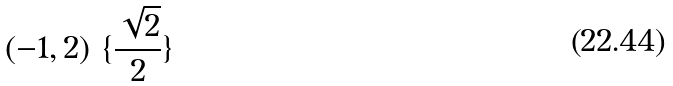<formula> <loc_0><loc_0><loc_500><loc_500>( - 1 , 2 ) \ \{ \frac { \sqrt { 2 } } { 2 } \}</formula> 